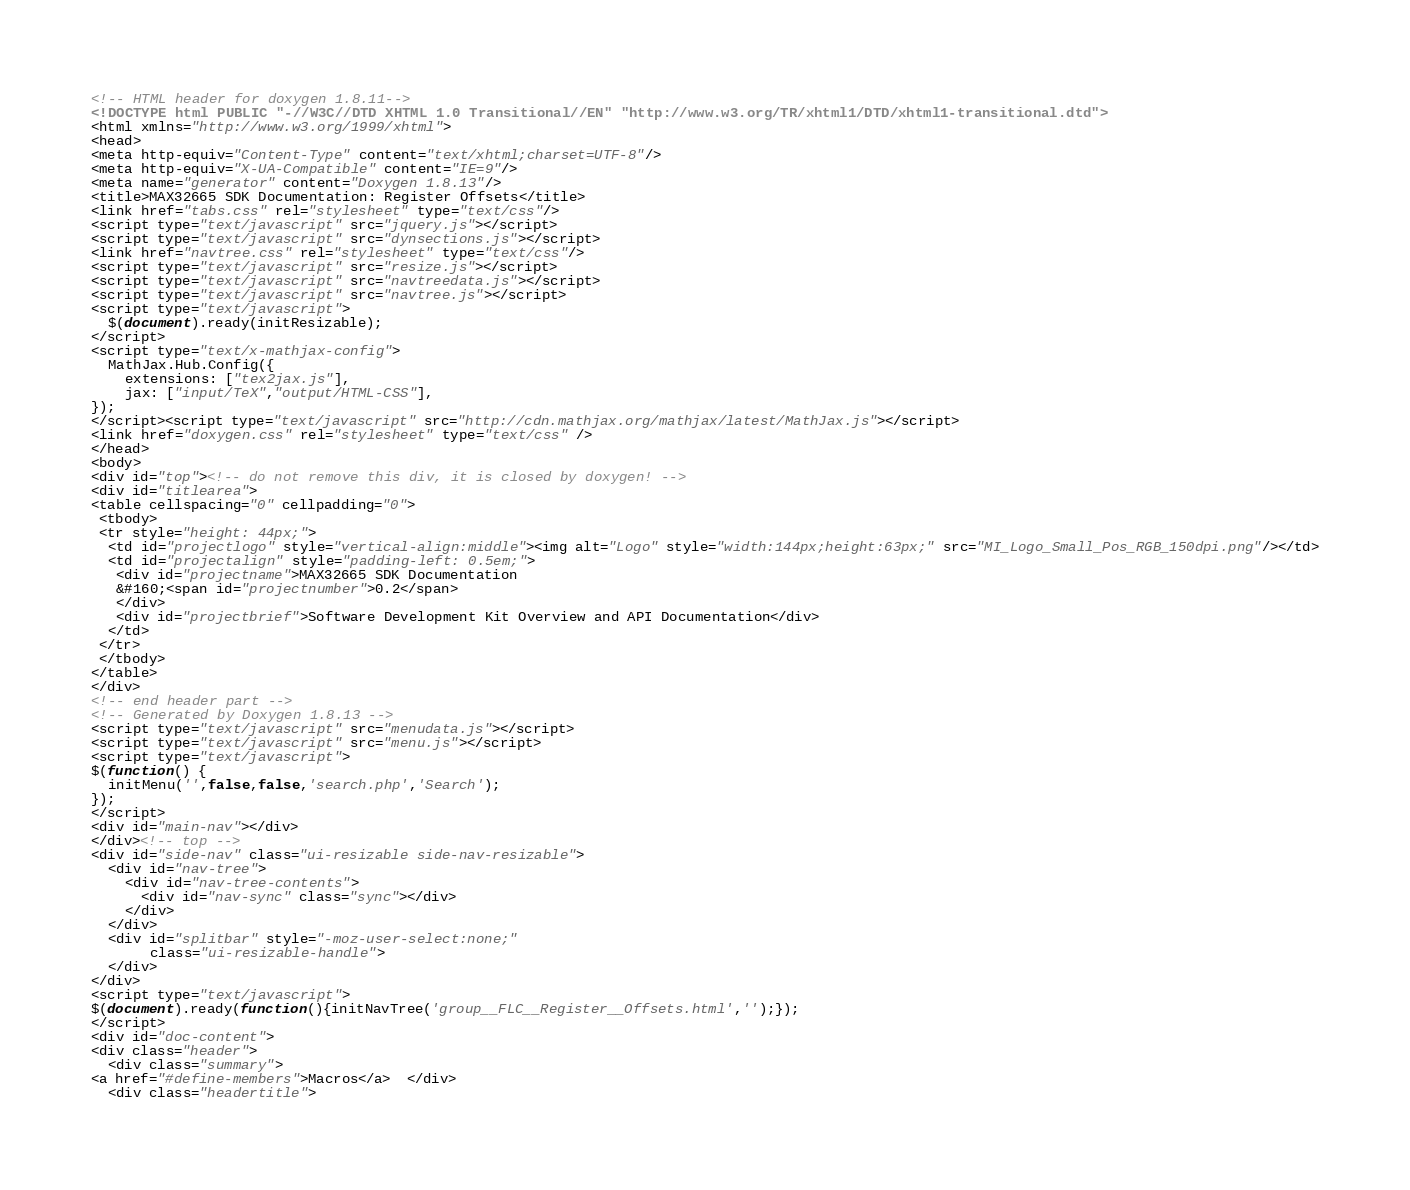Convert code to text. <code><loc_0><loc_0><loc_500><loc_500><_HTML_><!-- HTML header for doxygen 1.8.11-->
<!DOCTYPE html PUBLIC "-//W3C//DTD XHTML 1.0 Transitional//EN" "http://www.w3.org/TR/xhtml1/DTD/xhtml1-transitional.dtd">
<html xmlns="http://www.w3.org/1999/xhtml">
<head>
<meta http-equiv="Content-Type" content="text/xhtml;charset=UTF-8"/>
<meta http-equiv="X-UA-Compatible" content="IE=9"/>
<meta name="generator" content="Doxygen 1.8.13"/>
<title>MAX32665 SDK Documentation: Register Offsets</title>
<link href="tabs.css" rel="stylesheet" type="text/css"/>
<script type="text/javascript" src="jquery.js"></script>
<script type="text/javascript" src="dynsections.js"></script>
<link href="navtree.css" rel="stylesheet" type="text/css"/>
<script type="text/javascript" src="resize.js"></script>
<script type="text/javascript" src="navtreedata.js"></script>
<script type="text/javascript" src="navtree.js"></script>
<script type="text/javascript">
  $(document).ready(initResizable);
</script>
<script type="text/x-mathjax-config">
  MathJax.Hub.Config({
    extensions: ["tex2jax.js"],
    jax: ["input/TeX","output/HTML-CSS"],
});
</script><script type="text/javascript" src="http://cdn.mathjax.org/mathjax/latest/MathJax.js"></script>
<link href="doxygen.css" rel="stylesheet" type="text/css" />
</head>
<body>
<div id="top"><!-- do not remove this div, it is closed by doxygen! -->
<div id="titlearea">
<table cellspacing="0" cellpadding="0">
 <tbody>
 <tr style="height: 44px;">
  <td id="projectlogo" style="vertical-align:middle"><img alt="Logo" style="width:144px;height:63px;" src="MI_Logo_Small_Pos_RGB_150dpi.png"/></td>
  <td id="projectalign" style="padding-left: 0.5em;">
   <div id="projectname">MAX32665 SDK Documentation
   &#160;<span id="projectnumber">0.2</span>
   </div>
   <div id="projectbrief">Software Development Kit Overview and API Documentation</div>
  </td>
 </tr>
 </tbody>
</table>
</div>
<!-- end header part -->
<!-- Generated by Doxygen 1.8.13 -->
<script type="text/javascript" src="menudata.js"></script>
<script type="text/javascript" src="menu.js"></script>
<script type="text/javascript">
$(function() {
  initMenu('',false,false,'search.php','Search');
});
</script>
<div id="main-nav"></div>
</div><!-- top -->
<div id="side-nav" class="ui-resizable side-nav-resizable">
  <div id="nav-tree">
    <div id="nav-tree-contents">
      <div id="nav-sync" class="sync"></div>
    </div>
  </div>
  <div id="splitbar" style="-moz-user-select:none;" 
       class="ui-resizable-handle">
  </div>
</div>
<script type="text/javascript">
$(document).ready(function(){initNavTree('group__FLC__Register__Offsets.html','');});
</script>
<div id="doc-content">
<div class="header">
  <div class="summary">
<a href="#define-members">Macros</a>  </div>
  <div class="headertitle"></code> 